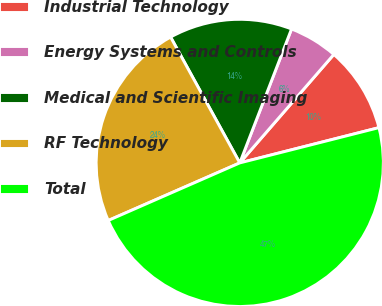Convert chart. <chart><loc_0><loc_0><loc_500><loc_500><pie_chart><fcel>Industrial Technology<fcel>Energy Systems and Controls<fcel>Medical and Scientific Imaging<fcel>RF Technology<fcel>Total<nl><fcel>9.68%<fcel>5.5%<fcel>13.87%<fcel>23.57%<fcel>47.38%<nl></chart> 